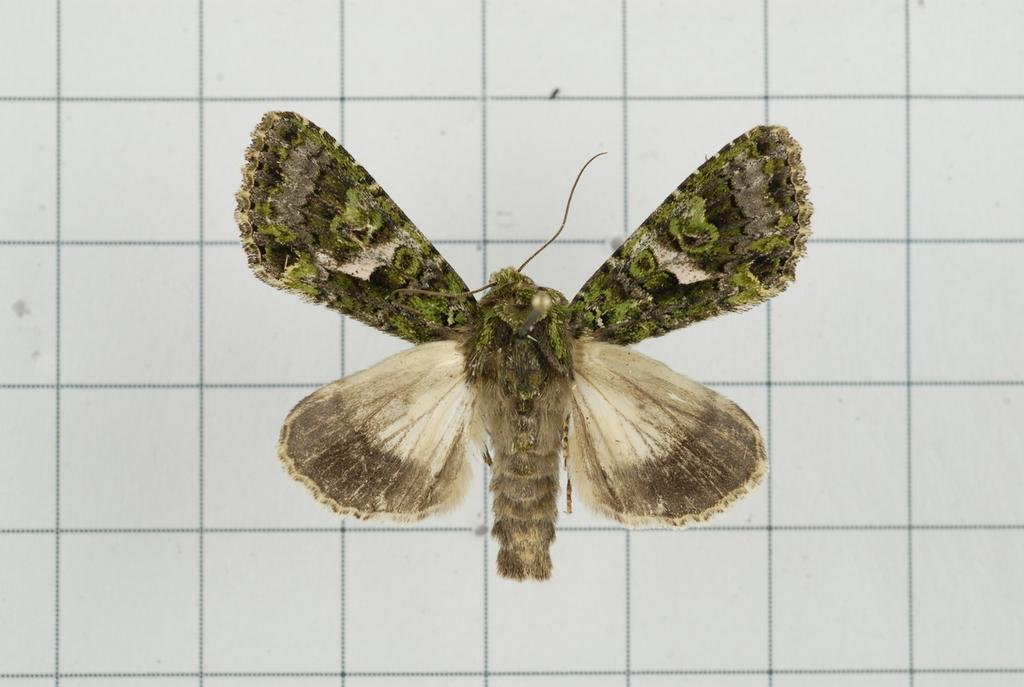What type of animals can be seen in the image? There are butterflies in the image. Can you describe the variety of butterflies in the image? The butterflies are of different kinds. Where are the butterflies located in the image? The butterflies are standing on a wall. What type of drug can be seen on the toes of the butterflies in the image? There is no drug or reference to toes in the image, as it features butterflies standing on a wall. 